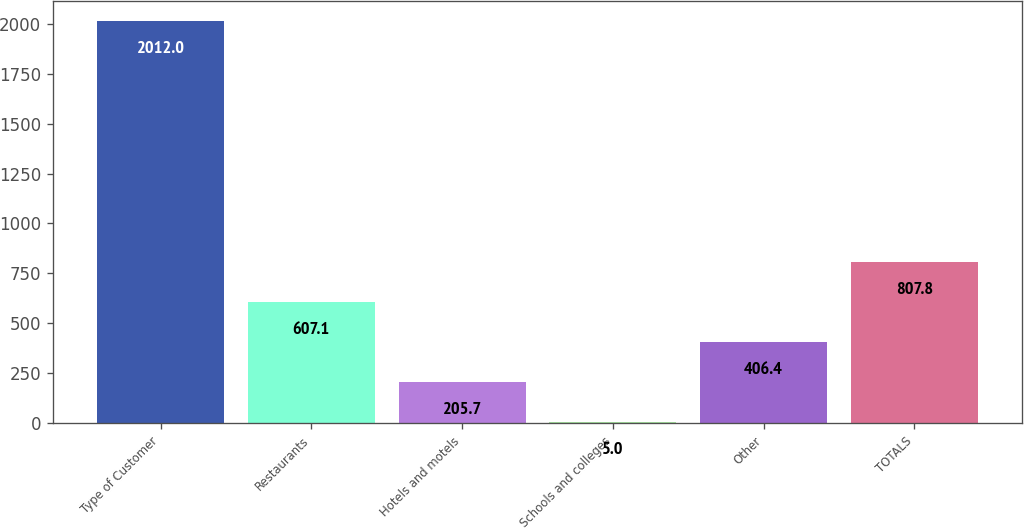<chart> <loc_0><loc_0><loc_500><loc_500><bar_chart><fcel>Type of Customer<fcel>Restaurants<fcel>Hotels and motels<fcel>Schools and colleges<fcel>Other<fcel>TOTALS<nl><fcel>2012<fcel>607.1<fcel>205.7<fcel>5<fcel>406.4<fcel>807.8<nl></chart> 